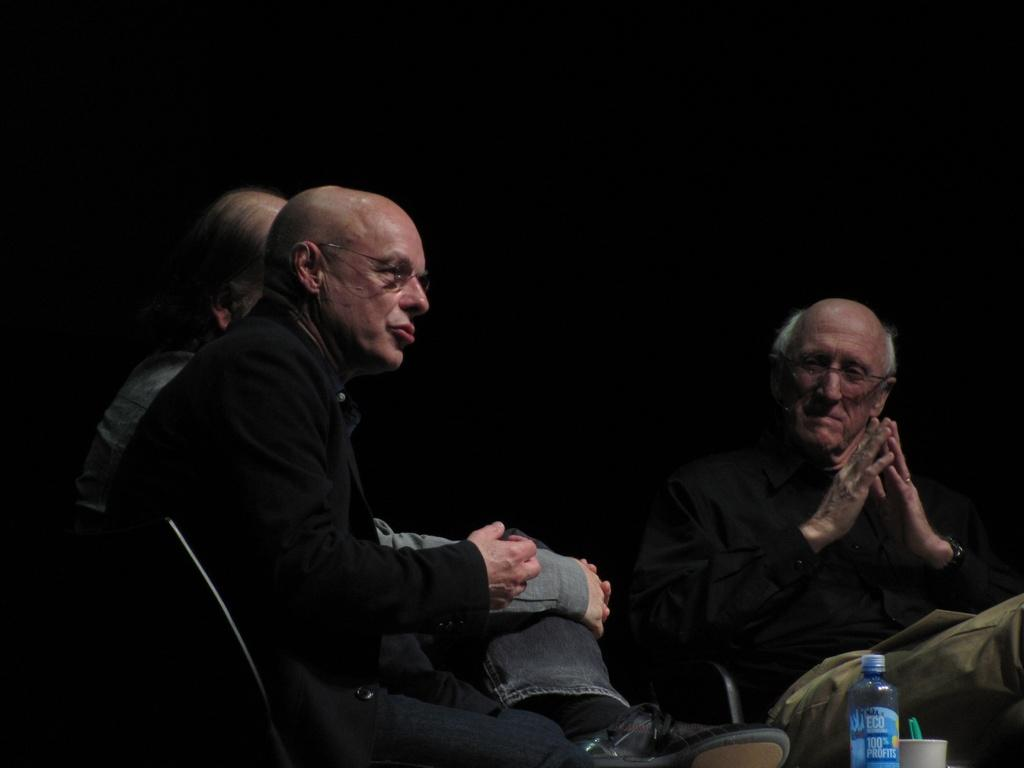How many people are in the image? There are three people in the image. What are the people doing in the image? The people are sitting on chairs. Where are the chairs located in relation to the table? The chairs are in front of a table. What objects can be seen on the table? There is a bottle and a bowl on the table. What is the color of the background in the image? The background of the image is black. What type of thread is being used by the frog to climb the steel structure in the image? There is no frog or steel structure present in the image. 